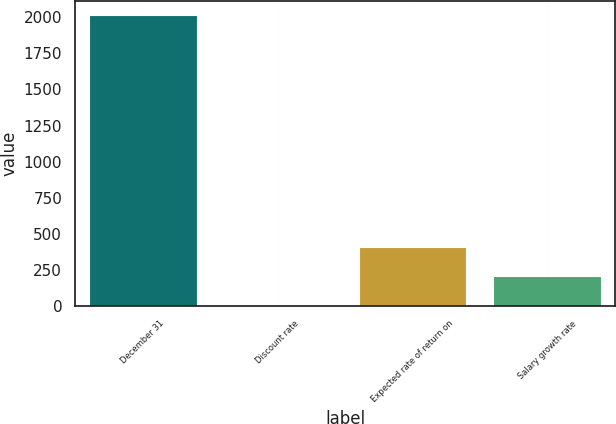Convert chart. <chart><loc_0><loc_0><loc_500><loc_500><bar_chart><fcel>December 31<fcel>Discount rate<fcel>Expected rate of return on<fcel>Salary growth rate<nl><fcel>2013<fcel>4.1<fcel>405.88<fcel>204.99<nl></chart> 